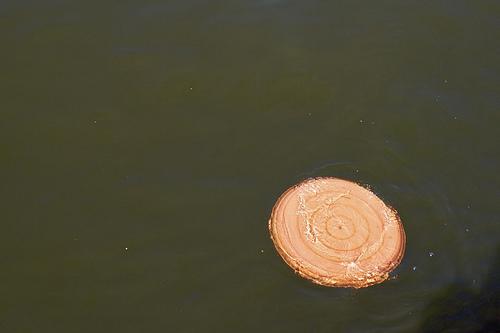Is the object floating?
Give a very brief answer. Yes. Is that a lake?
Keep it brief. Yes. What is the object on top of?
Short answer required. Water. 